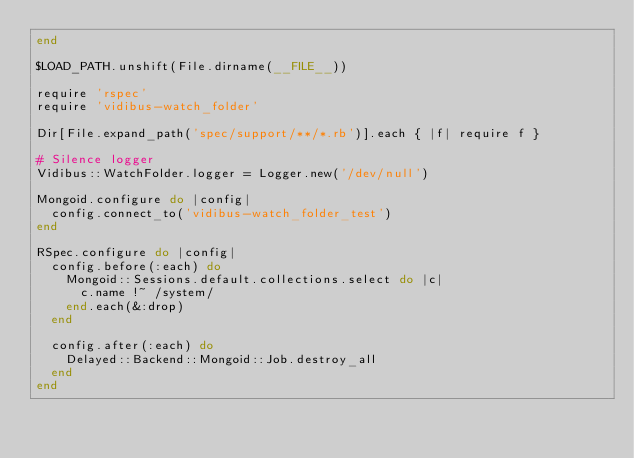<code> <loc_0><loc_0><loc_500><loc_500><_Ruby_>end

$LOAD_PATH.unshift(File.dirname(__FILE__))

require 'rspec'
require 'vidibus-watch_folder'

Dir[File.expand_path('spec/support/**/*.rb')].each { |f| require f }

# Silence logger
Vidibus::WatchFolder.logger = Logger.new('/dev/null')

Mongoid.configure do |config|
  config.connect_to('vidibus-watch_folder_test')
end

RSpec.configure do |config|
  config.before(:each) do
    Mongoid::Sessions.default.collections.select do |c|
      c.name !~ /system/
    end.each(&:drop)
  end

  config.after(:each) do
    Delayed::Backend::Mongoid::Job.destroy_all
  end
end
</code> 